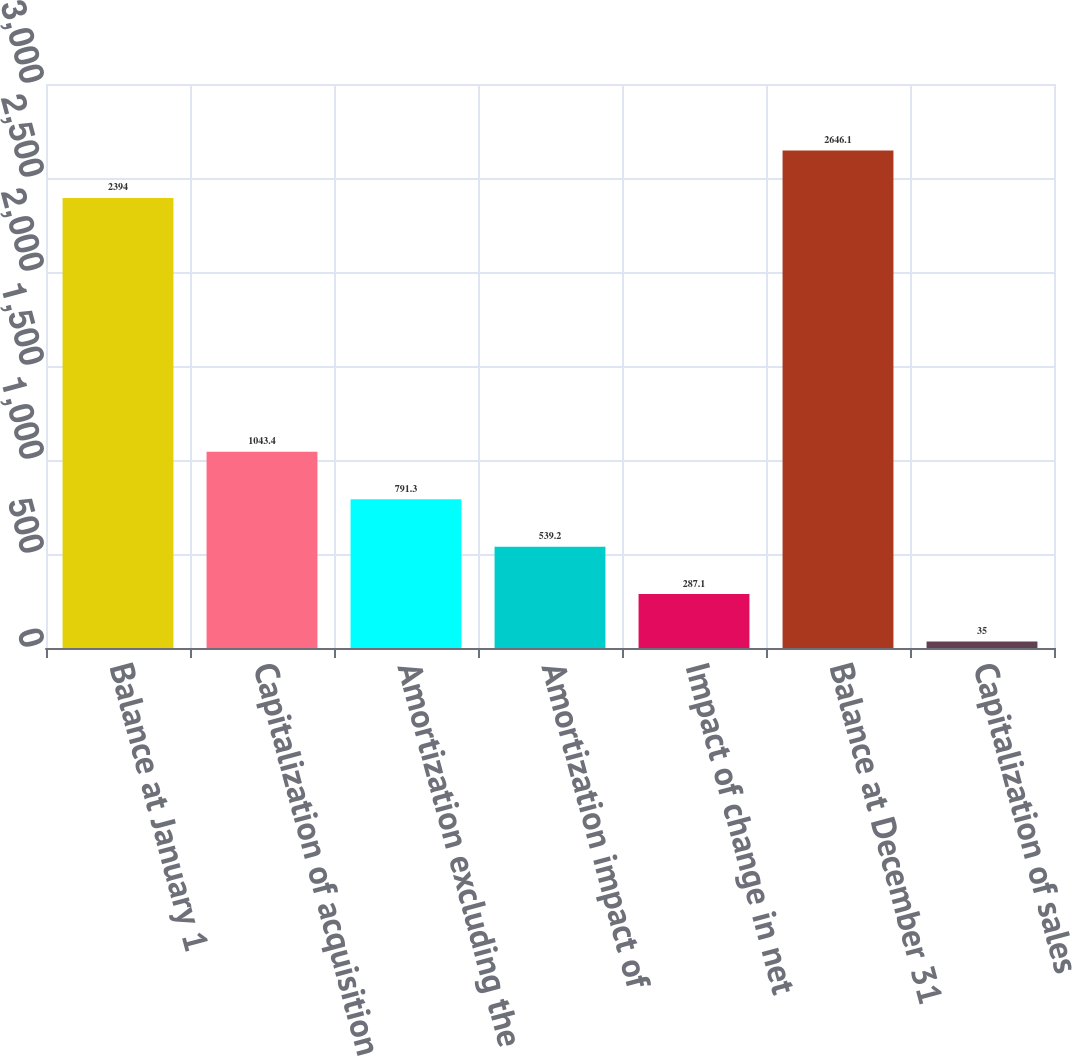Convert chart to OTSL. <chart><loc_0><loc_0><loc_500><loc_500><bar_chart><fcel>Balance at January 1<fcel>Capitalization of acquisition<fcel>Amortization excluding the<fcel>Amortization impact of<fcel>Impact of change in net<fcel>Balance at December 31<fcel>Capitalization of sales<nl><fcel>2394<fcel>1043.4<fcel>791.3<fcel>539.2<fcel>287.1<fcel>2646.1<fcel>35<nl></chart> 